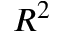Convert formula to latex. <formula><loc_0><loc_0><loc_500><loc_500>R ^ { 2 }</formula> 